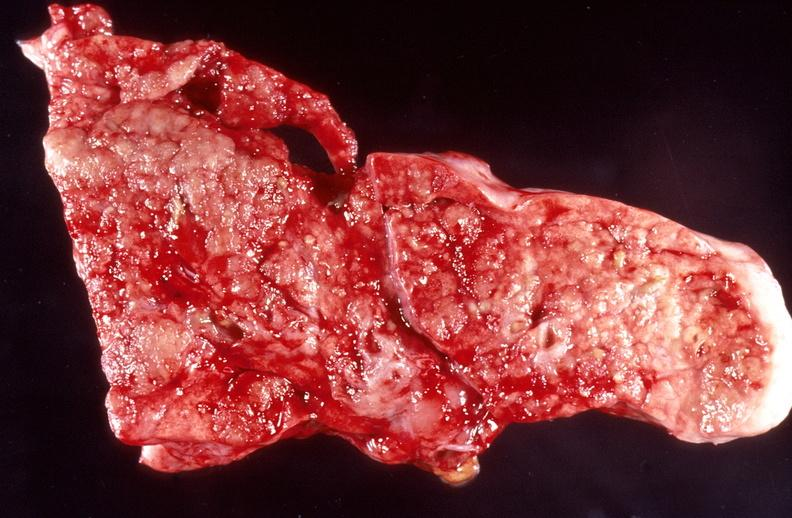does this image show lung, bronchopneumonia, cystic fibrosis?
Answer the question using a single word or phrase. Yes 